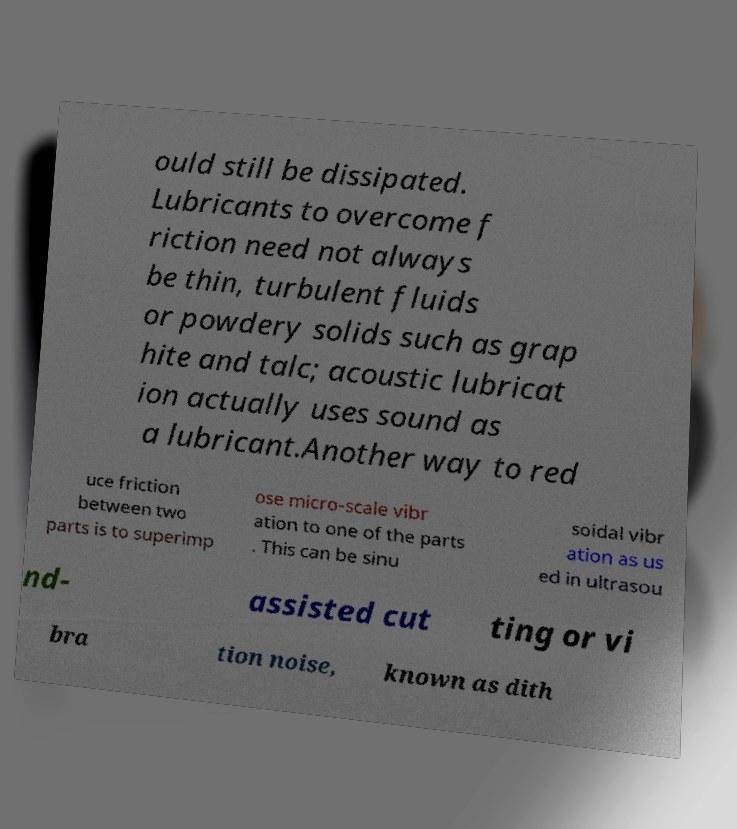Please identify and transcribe the text found in this image. ould still be dissipated. Lubricants to overcome f riction need not always be thin, turbulent fluids or powdery solids such as grap hite and talc; acoustic lubricat ion actually uses sound as a lubricant.Another way to red uce friction between two parts is to superimp ose micro-scale vibr ation to one of the parts . This can be sinu soidal vibr ation as us ed in ultrasou nd- assisted cut ting or vi bra tion noise, known as dith 